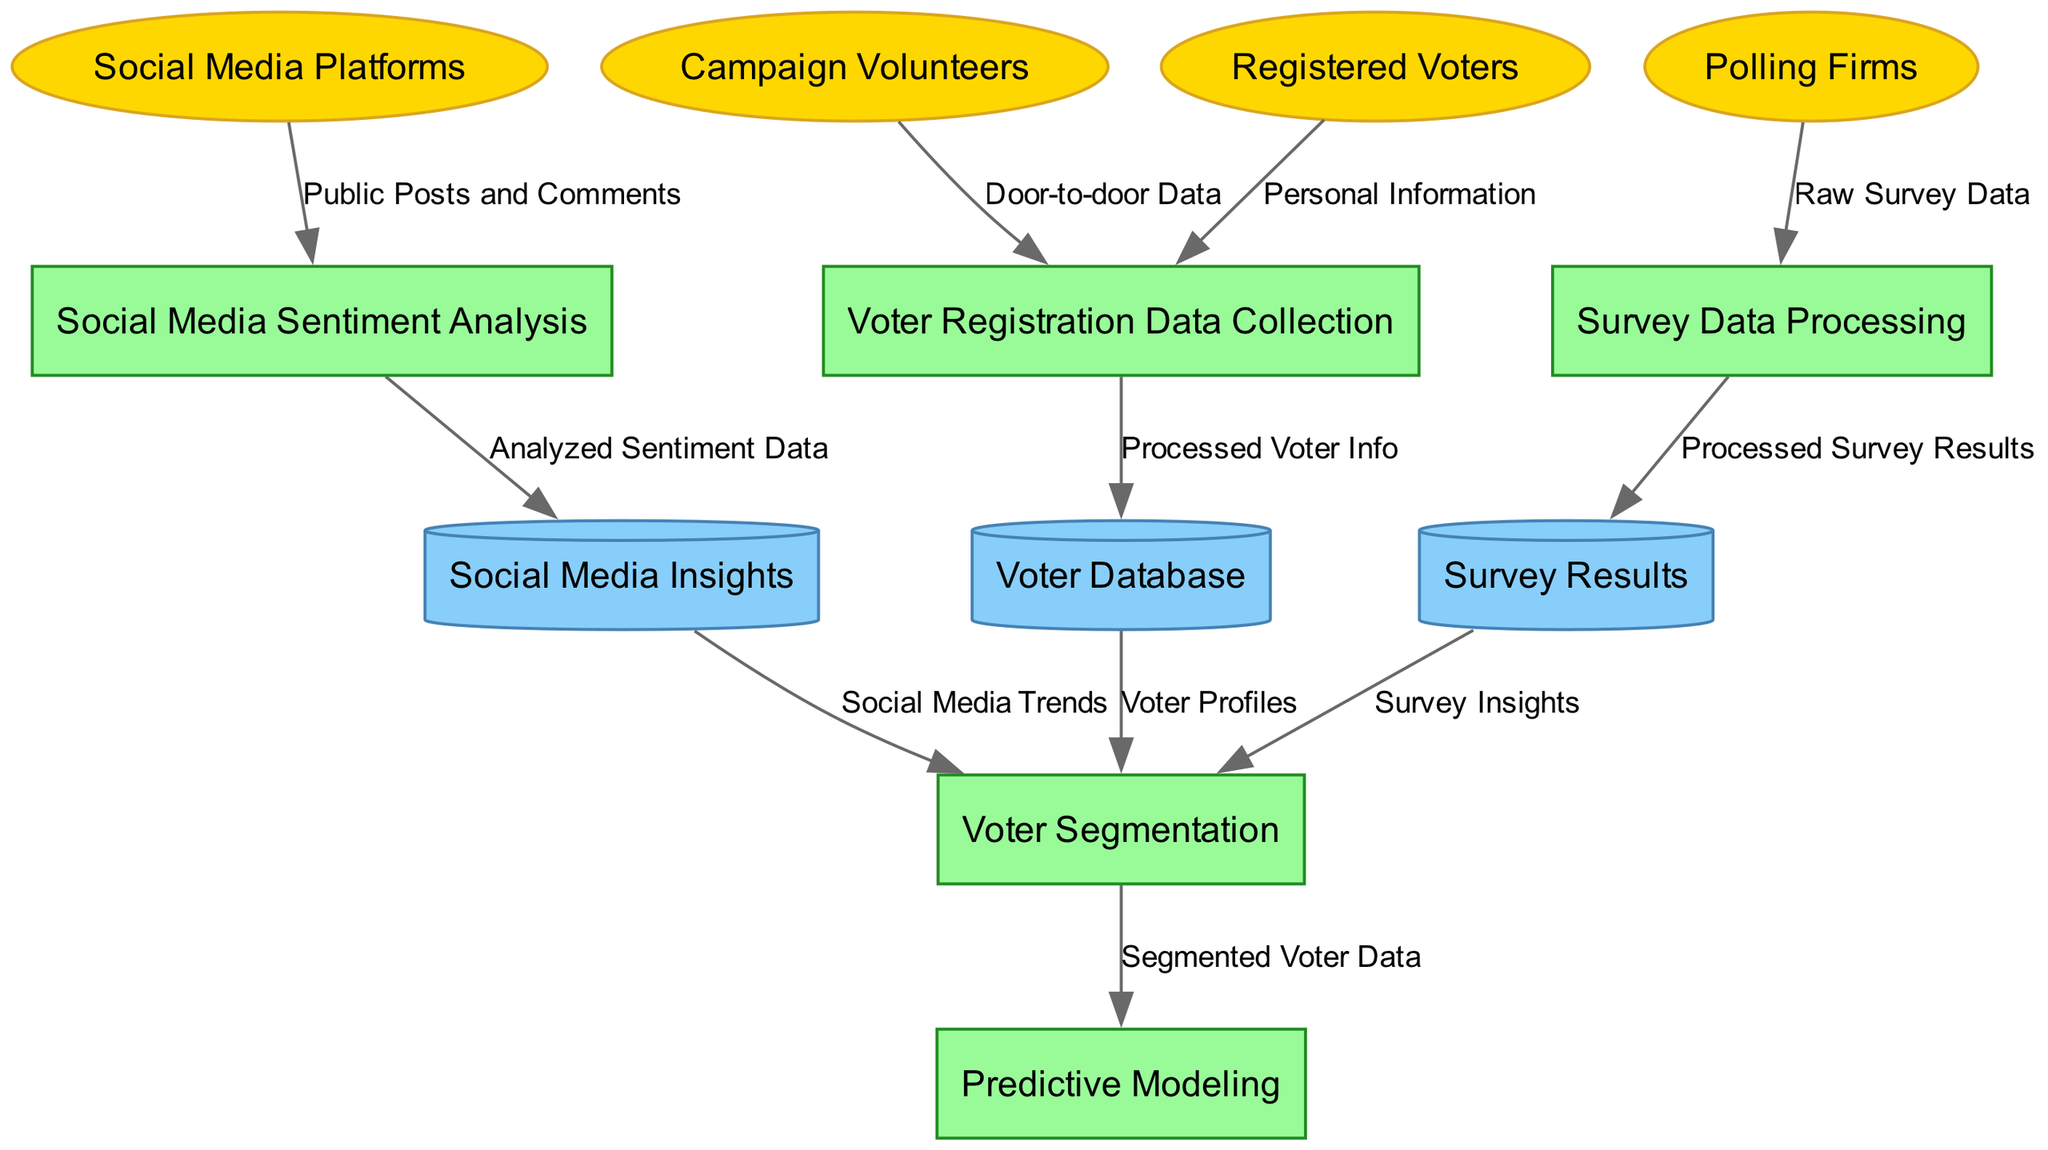What are the external entities in this diagram? The external entities are identified by the elliptical nodes on the diagram's outer layer. The diagram lists the entities as Registered Voters, Campaign Volunteers, Social Media Platforms, and Polling Firms.
Answer: Registered Voters, Campaign Volunteers, Social Media Platforms, Polling Firms How many processes are shown in the diagram? To determine the count of processes, we look at the rectangular nodes in the diagram. There are five processes indicated: Voter Registration Data Collection, Social Media Sentiment Analysis, Survey Data Processing, Voter Segmentation, and Predictive Modeling.
Answer: 5 What is the data flow from Polling Firms labeled as? The labeling of data flows is shown on the edges connecting nodes. The edge from Polling Firms to Survey Data Processing is labeled as "Raw Survey Data."
Answer: Raw Survey Data Which process receives the "Processed Voter Info"? To find which process receives this data, we trace the flow from the Voter Registration Data Collection, which sends "Processed Voter Info" to the Voter Database. Therefore, the next step would involve the Voter Database.
Answer: Voter Database What type of analysis does the process "Social Media Sentiment Analysis" utilize? The data flowing into Social Media Sentiment Analysis comes from Social Media Platforms, specifically the edge labeled "Public Posts and Comments." This indicates that the analysis focuses on sentiment gathered from public posts and comments on social media.
Answer: Sentiment Analysis of Public Posts and Comments How many data stores exist in the diagram? The number of data stores can be counted by identifying the cylindrical nodes. There are three data stores: Voter Database, Social Media Insights, and Survey Results.
Answer: 3 What type of data is used in the process "Predictive Modeling"? "Predictive Modeling" receives data from the process "Voter Segmentation." The edge labeled "Segmented Voter Data" indicates that this is the type of data used in the predictive modeling process.
Answer: Segmented Voter Data What connections flow into "Voter Segmentation"? To answer this, we look at the incoming edges to the Voter Segmentation process. Three flows enter: Voter Profiles from the Voter Database, Social Media Trends from Social Media Insights, and Survey Insights from Survey Results.
Answer: Voter Profiles, Social Media Trends, Survey Insights What kind of volunteers contribute to Voter Registration Data Collection? The edge from Campaign Volunteers to Voter Registration Data Collection indicates the type of contribution, labeled as "Door-to-door Data."
Answer: Door-to-door Data 